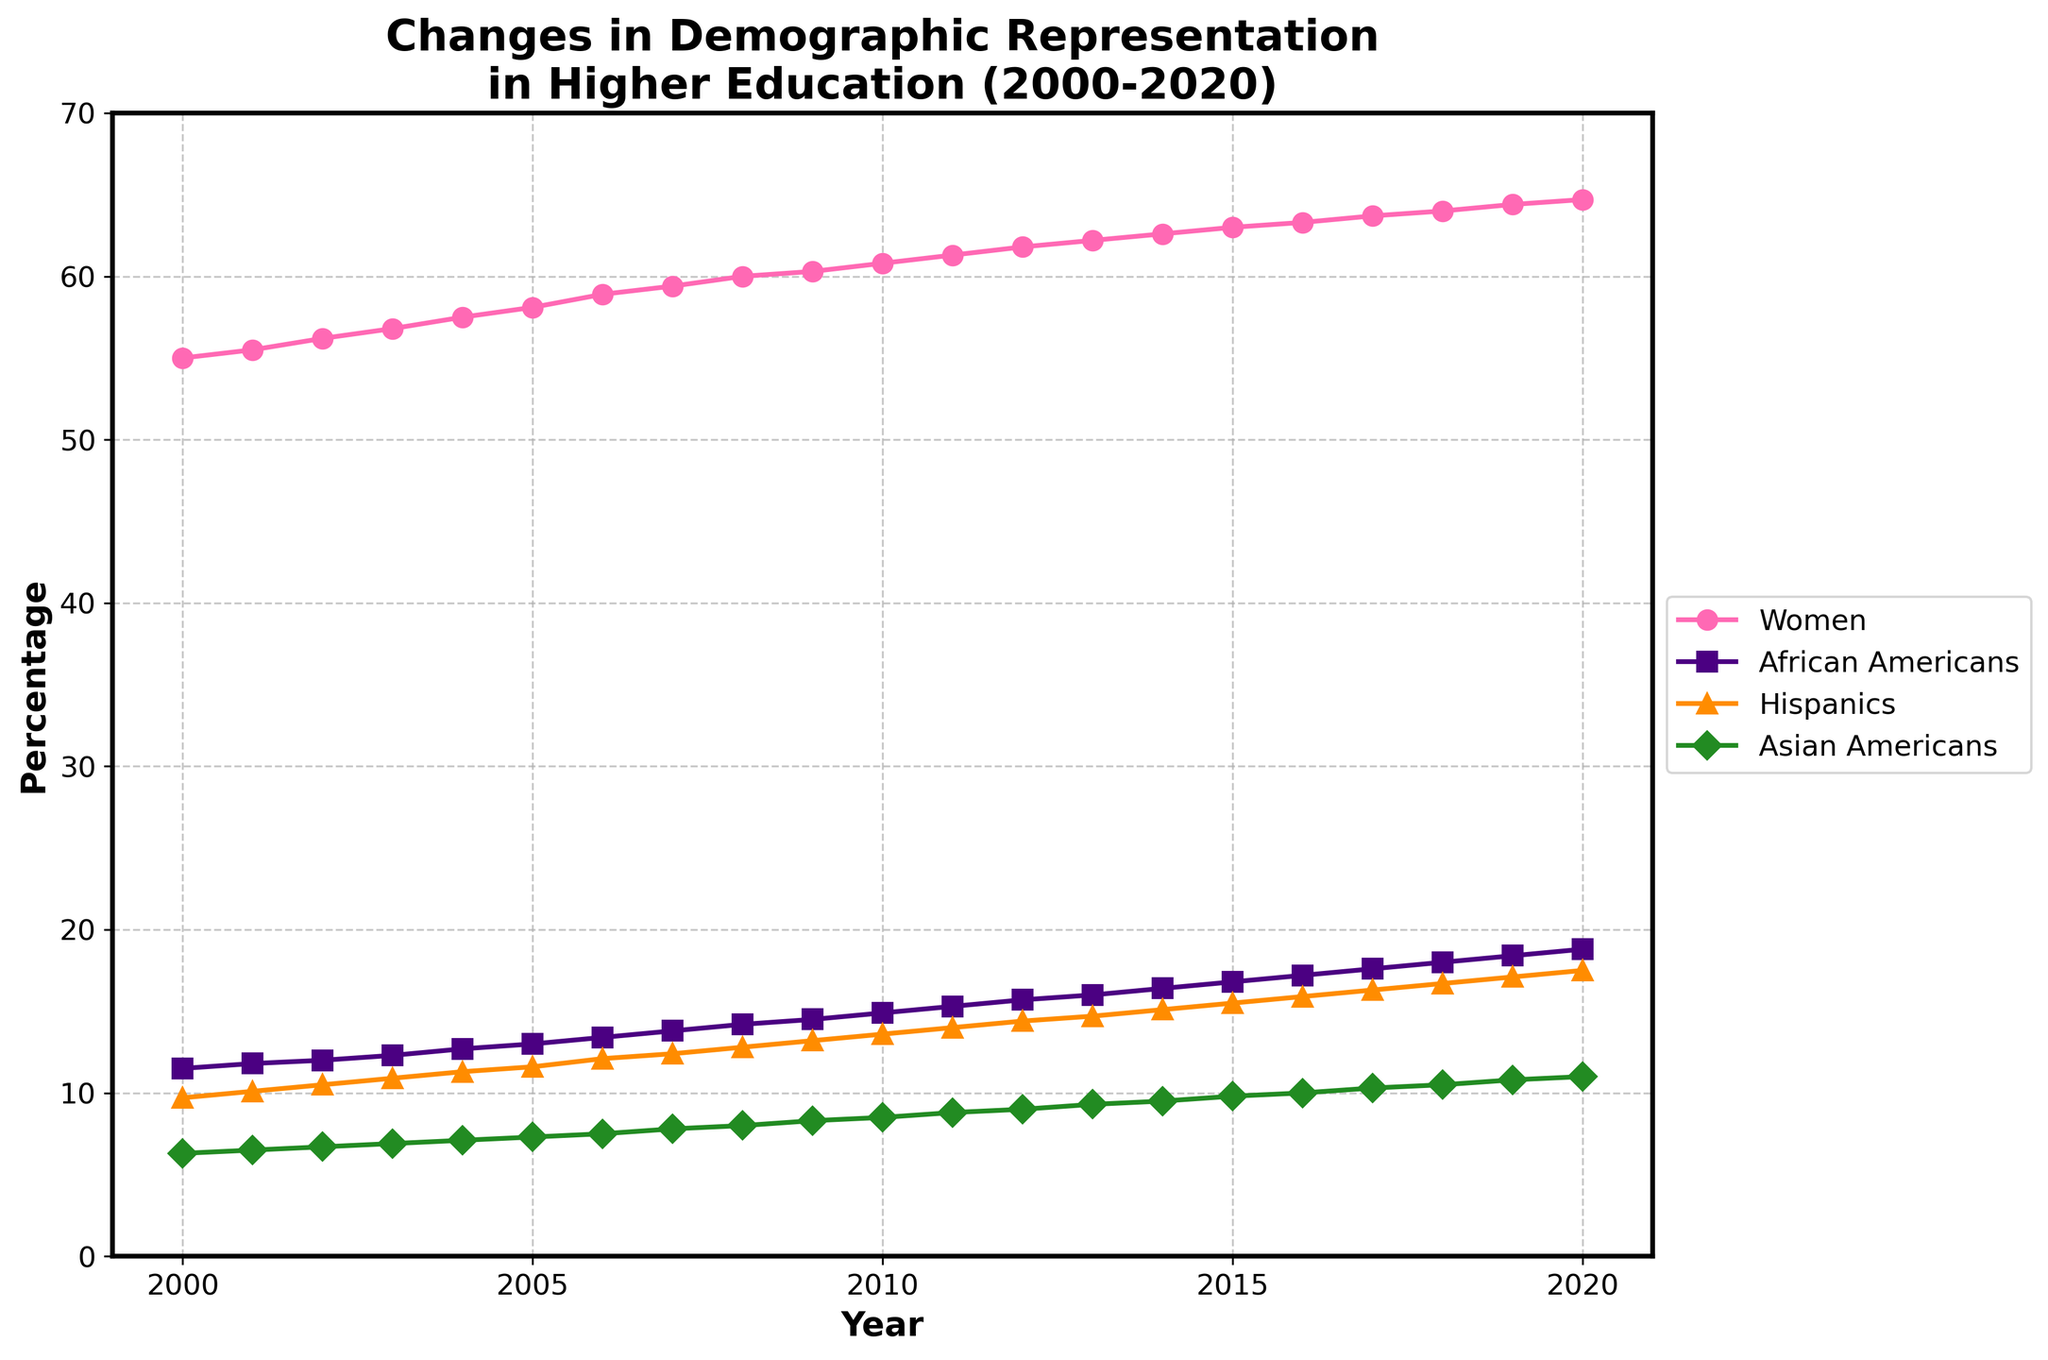How many different demographic groups are displayed in the figure? The figure has lines representing different demographics, visible distinctly by color and legend indications. By counting the unique colors and labels, we identify Women's Percentage, African Americans, Hispanics, and Asian Americans.
Answer: 4 What was the percentage of African Americans in colleges in the year 2012? Locate the data point for the year 2012 along the x-axis and follow it vertically until it intersects the line labeled African Americans marked by color and legend. The y-axis value at the intersection reveals the percentage.
Answer: 15.7% Which demographic group had the steepest increase in representation from 2000 to 2020? To determine the steepest increase, look at the initial and final values of each line representing different demographics. Calculate the increase for each group: Women (64.7-55.0), African Americans (18.8-11.5), Hispanics (17.5-9.7), Asian Americans (11.0-6.3). Compare these differences.
Answer: Women By how many percentage points did the representation of Hispanics in colleges change from 2000 to 2020? Find the percentages for Hispanics in 2000 and 2020 from the y-axis by following the corresponding line. Subtract the 2000 value from the 2020 value to get the change.
Answer: 7.8 Which year saw the percentage of Asian Americans in colleges reach 10%? Identify the Asian Americans line by its color and legend. Look for the data point where this line intersects the 10% mark on the y-axis, and then read the corresponding year on the x-axis.
Answer: 2016 Compare the percentage increase in college representation of African Americans from 2005 to 2010 with that of Hispanics in the same period. For African Americans, subtract the 2005 value from the 2010 value (14.9-13.0). For Hispanics, subtract the 2005 value from the 2010 value (13.6-11.6). Compare these differences.
Answer: African Americans' increase is 1.9%, Hispanics' increase is 2.0% What is the overall trend in the percentage of Women in colleges from 2000 to 2020? Find the initial and final percentages of Women and observe the upward direction of the graph line from 2000 to 2020. This denotes an increasing trend.
Answer: Increasing How did the representation of Asian Americans in colleges change between 2007 and 2013? Locate the Asian Americans line and follow its points from 2007 to 2013. Determine the values for these years (7.8 in 2007 and 9.3 in 2013). Calculate the difference.
Answer: Increase by 1.5% Which demographic group had the highest representation in 2020? Check the final value for each demographic group at the 2020 mark on the x-axis and compare the y-axis values. The group with the highest percentage is the answer.
Answer: Women What was the average percentage of African Americans in colleges from 2000 to 2020? Sum the percentage values for African Americans from 2000 to 2020 and divide by the number of years (20). Sum = 11.5 + 11.8 + 12.0 + 12.3 + 12.7 + 13.0 + 13.4 + 13.8 + 14.2 + 14.5 + 14.9 + 15.3 + 15.7 + 16.0 + 16.4 + 16.8 + 17.2 + 17.6 + 18.0 + 18.4. Average = 287.3/20 = 14.365
Answer: 14.37% 